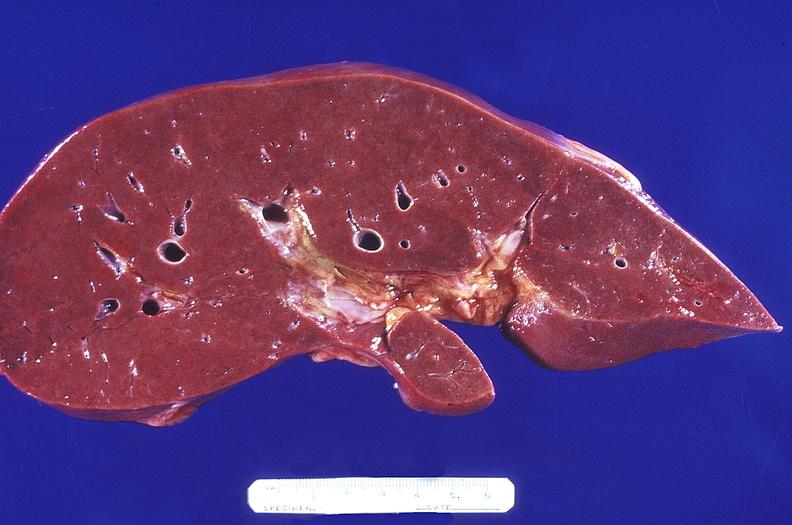does this image show normal liver?
Answer the question using a single word or phrase. Yes 